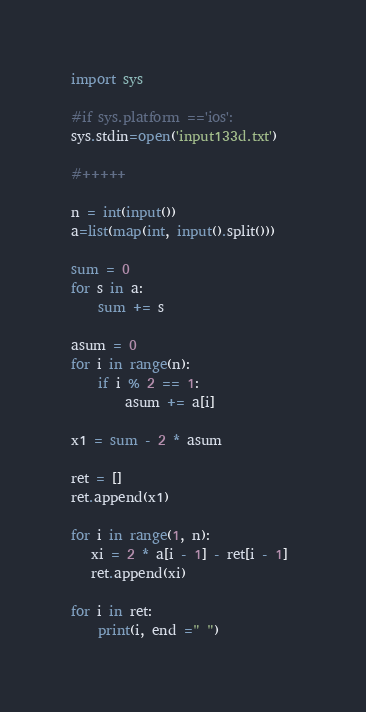Convert code to text. <code><loc_0><loc_0><loc_500><loc_500><_Python_>import sys

#if sys.platform =='ios':
sys.stdin=open('input133d.txt')

#+++++

n = int(input())
a=list(map(int, input().split()))

sum = 0
for s in a:
    sum += s

asum = 0
for i in range(n):
    if i % 2 == 1:
        asum += a[i]

x1 = sum - 2 * asum

ret = []
ret.append(x1)

for i in range(1, n):
   xi = 2 * a[i - 1] - ret[i - 1] 
   ret.append(xi)

for i in ret:
    print(i, end =" ")
</code> 